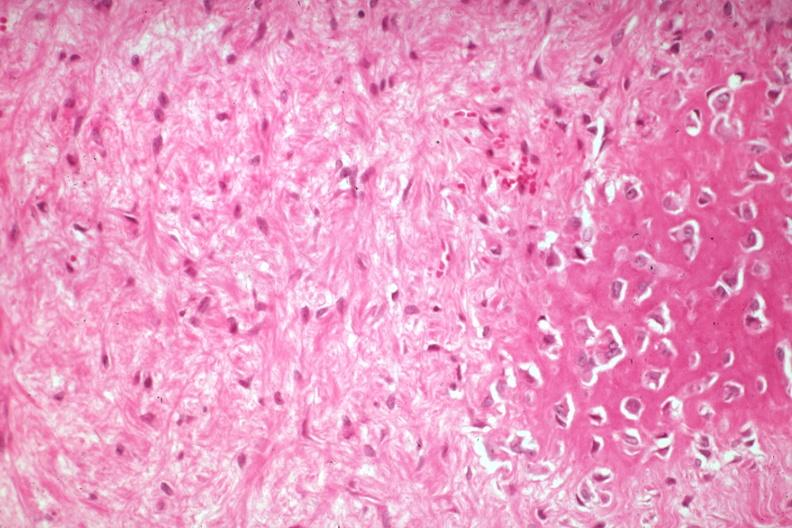does this image show high excessive fibrous callus with focal osteoid deposition and osteoblasts?
Answer the question using a single word or phrase. Yes 